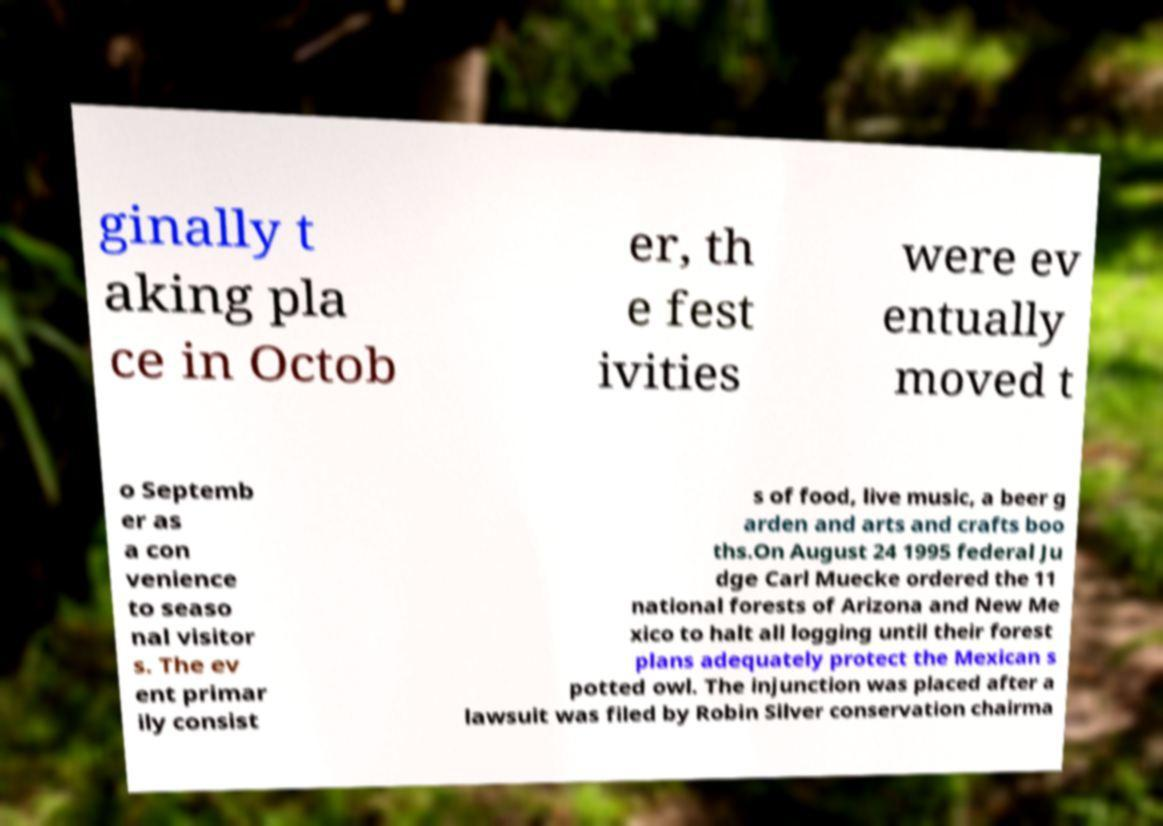Can you read and provide the text displayed in the image?This photo seems to have some interesting text. Can you extract and type it out for me? ginally t aking pla ce in Octob er, th e fest ivities were ev entually moved t o Septemb er as a con venience to seaso nal visitor s. The ev ent primar ily consist s of food, live music, a beer g arden and arts and crafts boo ths.On August 24 1995 federal Ju dge Carl Muecke ordered the 11 national forests of Arizona and New Me xico to halt all logging until their forest plans adequately protect the Mexican s potted owl. The injunction was placed after a lawsuit was filed by Robin Silver conservation chairma 